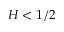Convert formula to latex. <formula><loc_0><loc_0><loc_500><loc_500>H < 1 / 2</formula> 